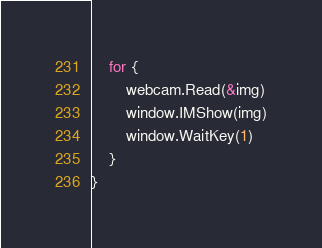<code> <loc_0><loc_0><loc_500><loc_500><_Go_>	for {
		webcam.Read(&img)
		window.IMShow(img)
		window.WaitKey(1)
	}
}
</code> 